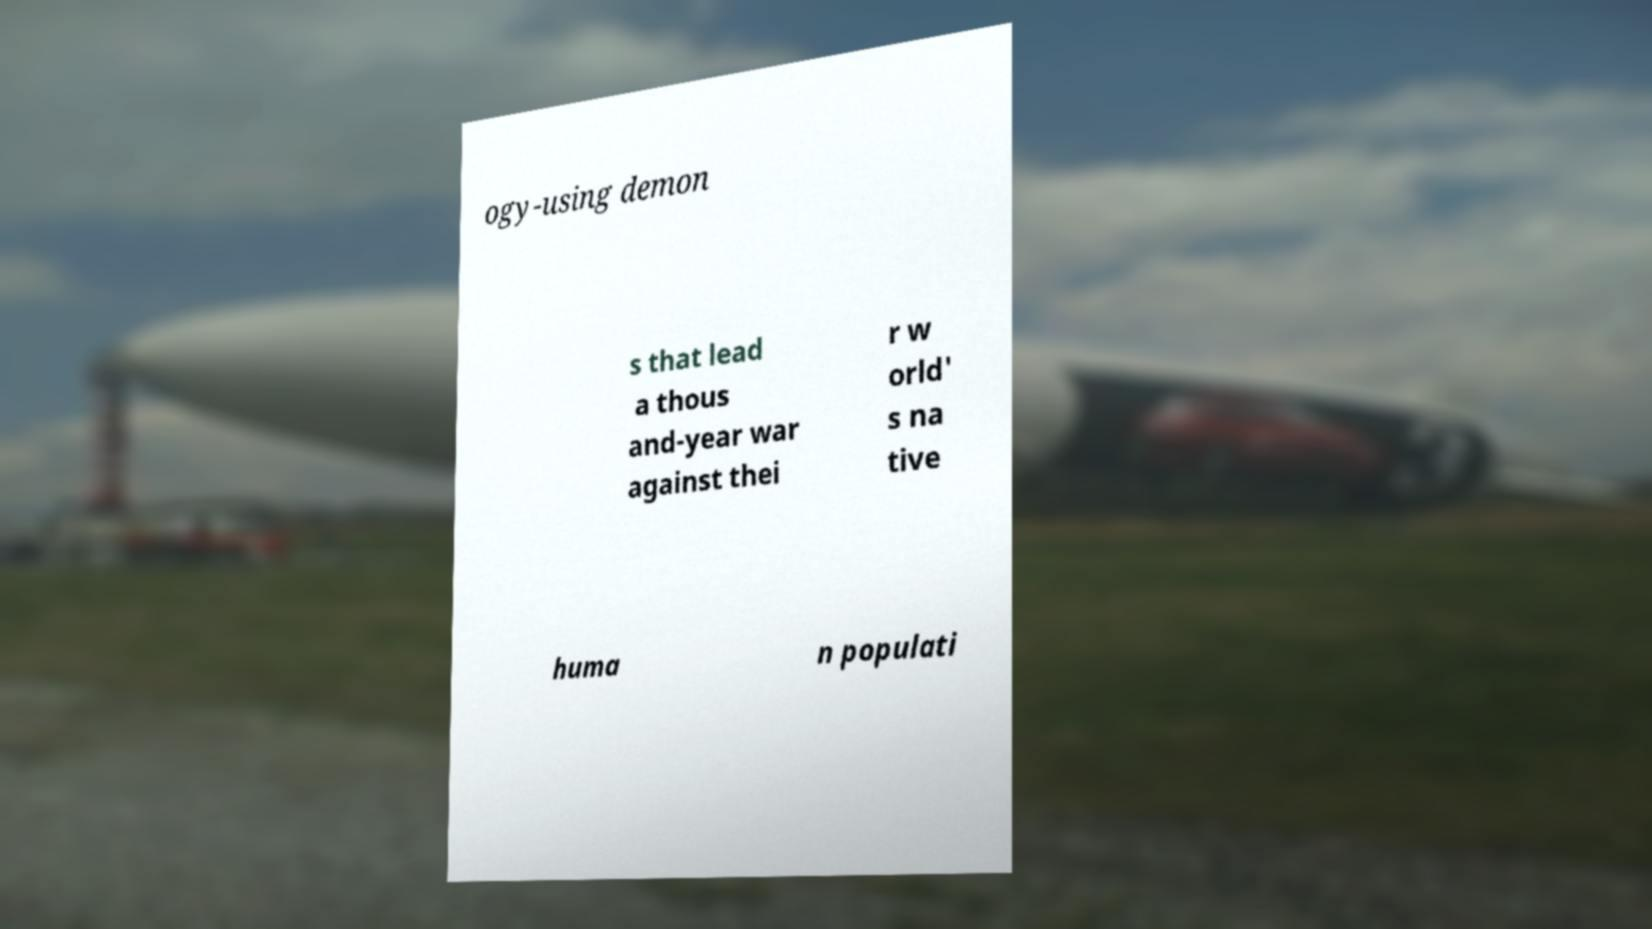Please read and relay the text visible in this image. What does it say? ogy-using demon s that lead a thous and-year war against thei r w orld' s na tive huma n populati 